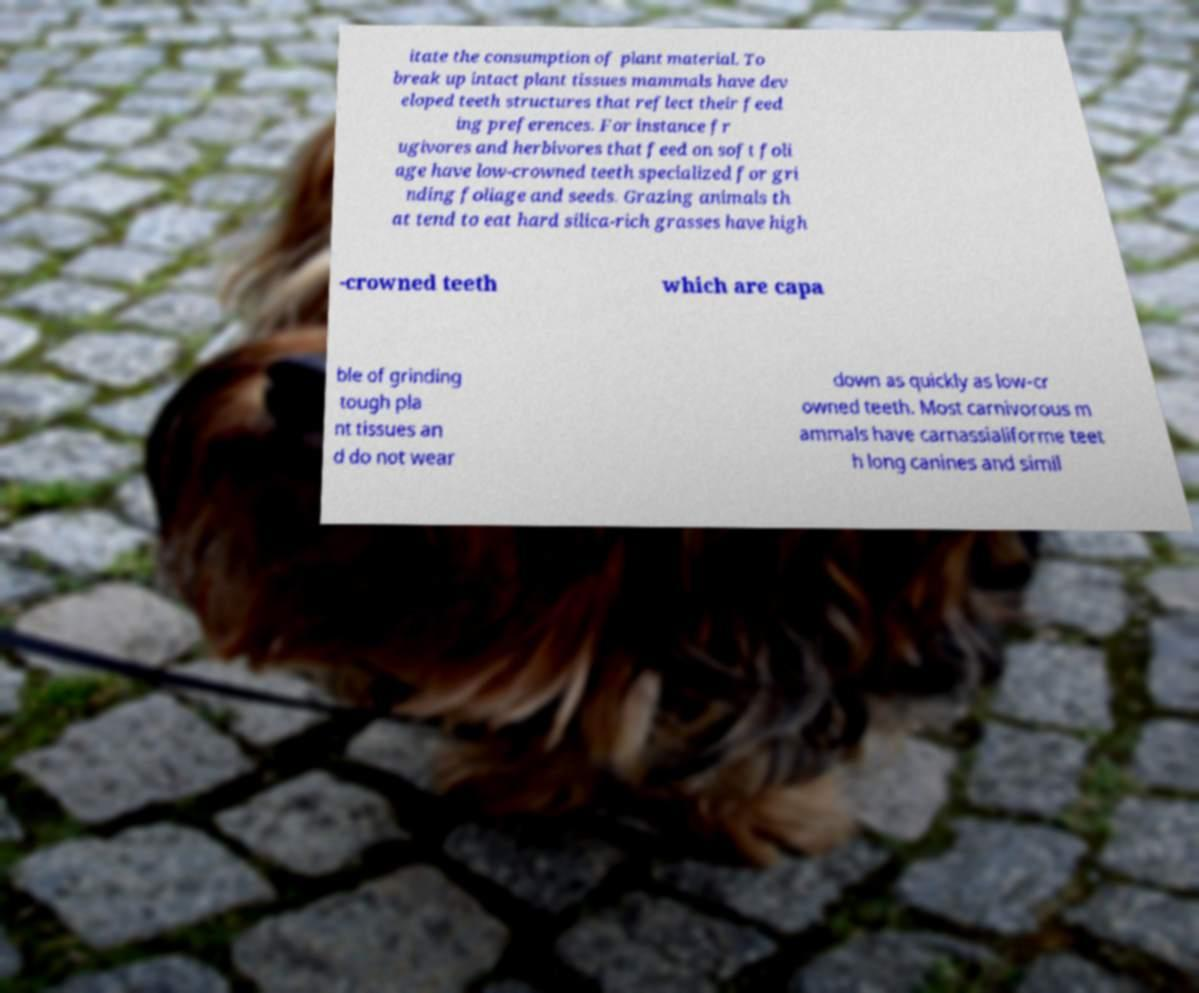What messages or text are displayed in this image? I need them in a readable, typed format. itate the consumption of plant material. To break up intact plant tissues mammals have dev eloped teeth structures that reflect their feed ing preferences. For instance fr ugivores and herbivores that feed on soft foli age have low-crowned teeth specialized for gri nding foliage and seeds. Grazing animals th at tend to eat hard silica-rich grasses have high -crowned teeth which are capa ble of grinding tough pla nt tissues an d do not wear down as quickly as low-cr owned teeth. Most carnivorous m ammals have carnassialiforme teet h long canines and simil 